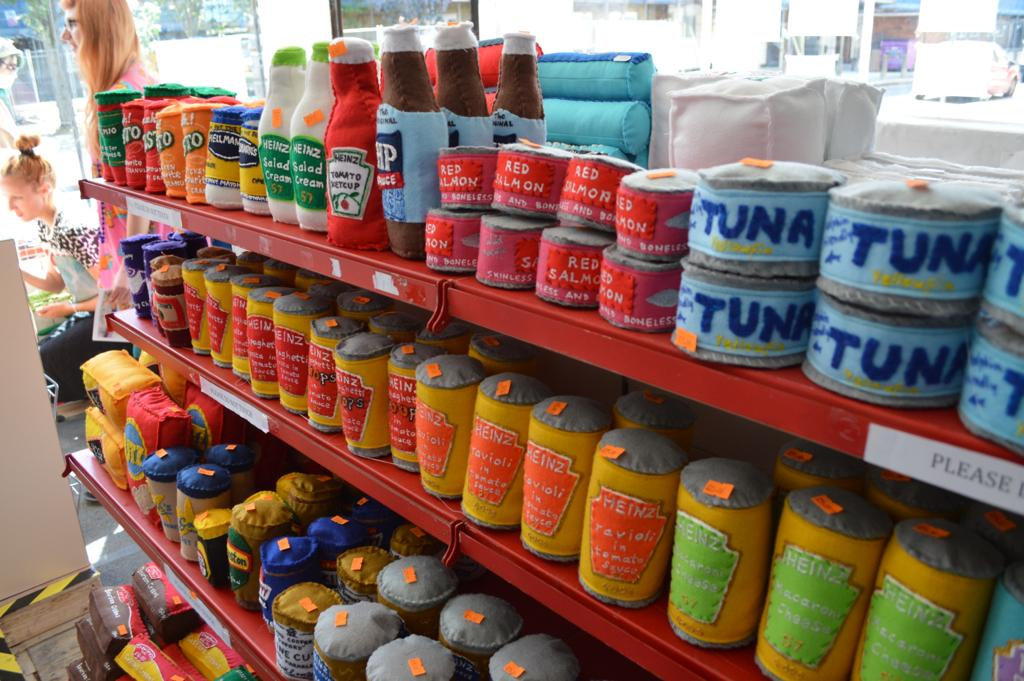<image>
Create a compact narrative representing the image presented. a shelf filled with stuffed toy food items on it including tuna. 